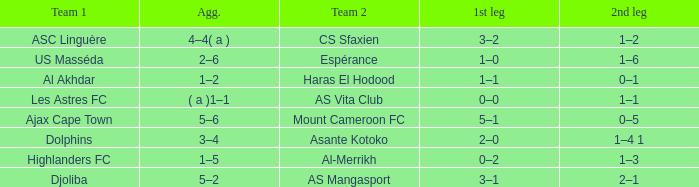What is the 2nd leg of team 1 Dolphins? 1–4 1. 